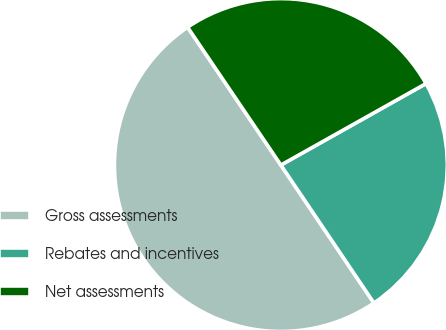Convert chart to OTSL. <chart><loc_0><loc_0><loc_500><loc_500><pie_chart><fcel>Gross assessments<fcel>Rebates and incentives<fcel>Net assessments<nl><fcel>49.98%<fcel>23.7%<fcel>26.33%<nl></chart> 